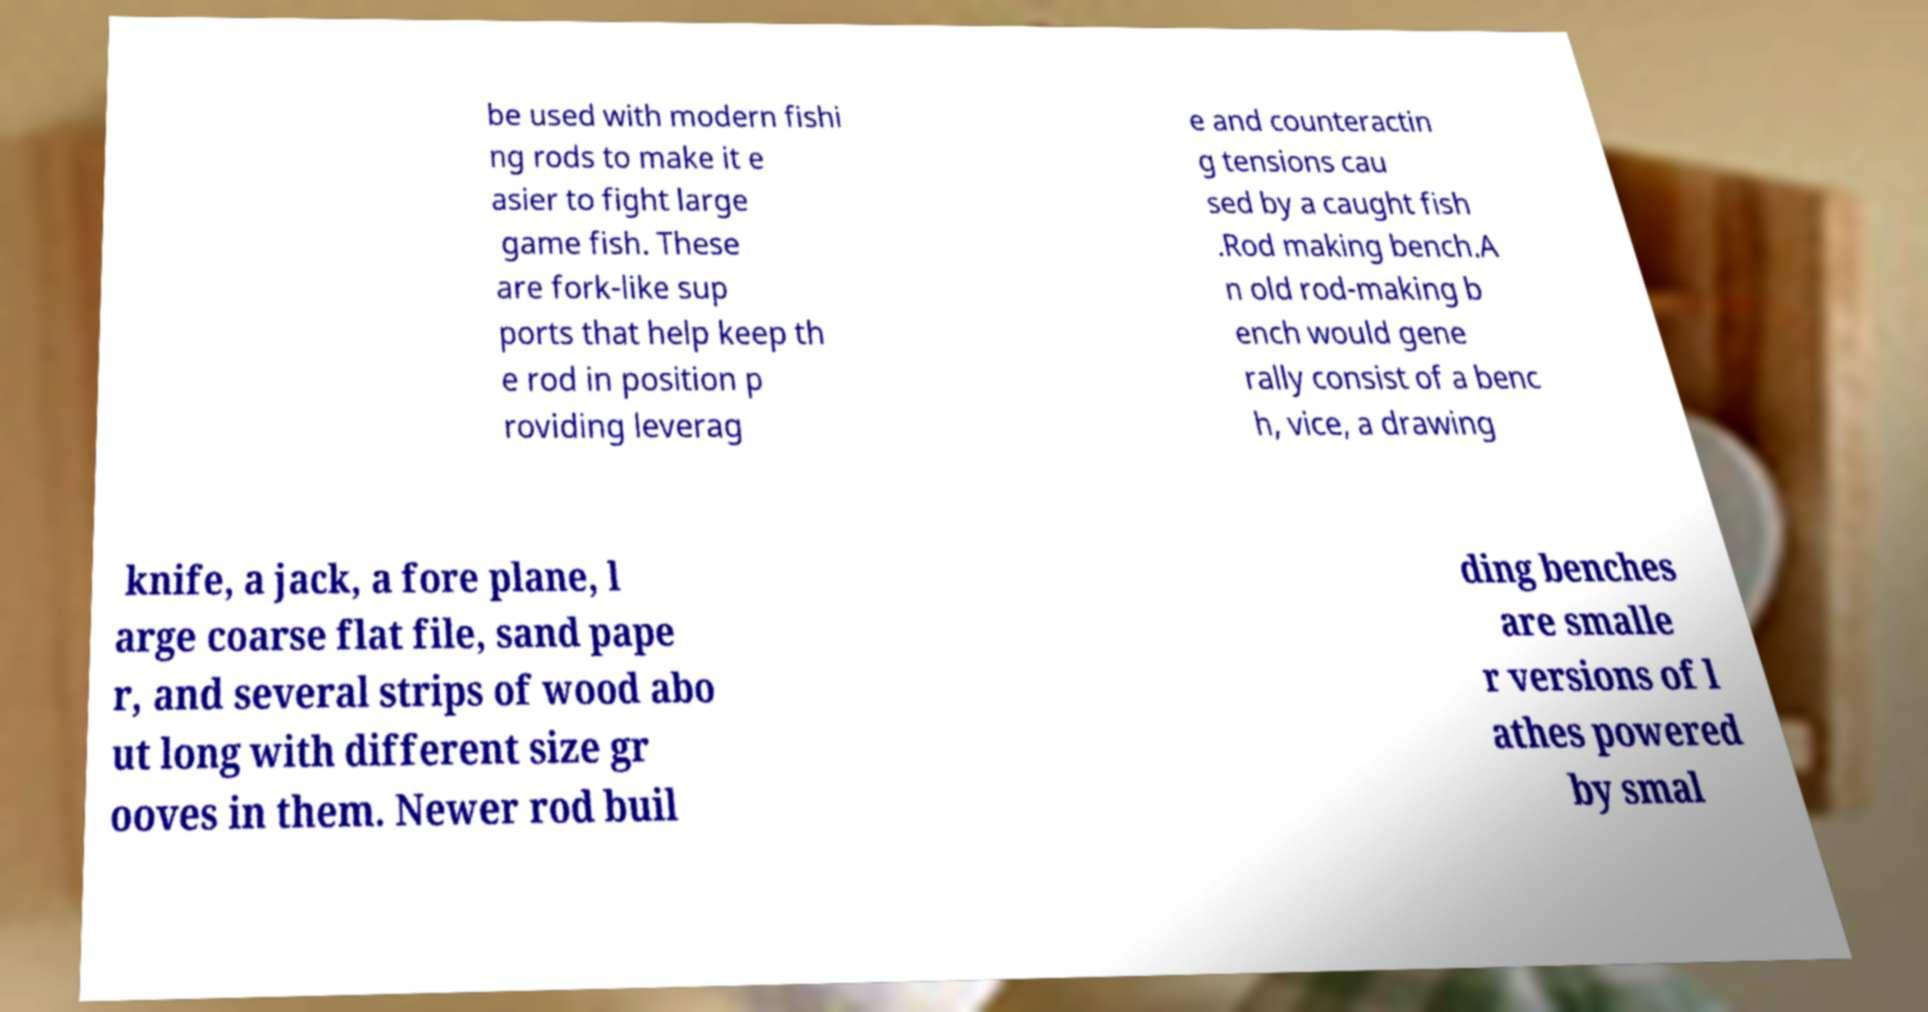Please read and relay the text visible in this image. What does it say? be used with modern fishi ng rods to make it e asier to fight large game fish. These are fork-like sup ports that help keep th e rod in position p roviding leverag e and counteractin g tensions cau sed by a caught fish .Rod making bench.A n old rod-making b ench would gene rally consist of a benc h, vice, a drawing knife, a jack, a fore plane, l arge coarse flat file, sand pape r, and several strips of wood abo ut long with different size gr ooves in them. Newer rod buil ding benches are smalle r versions of l athes powered by smal 